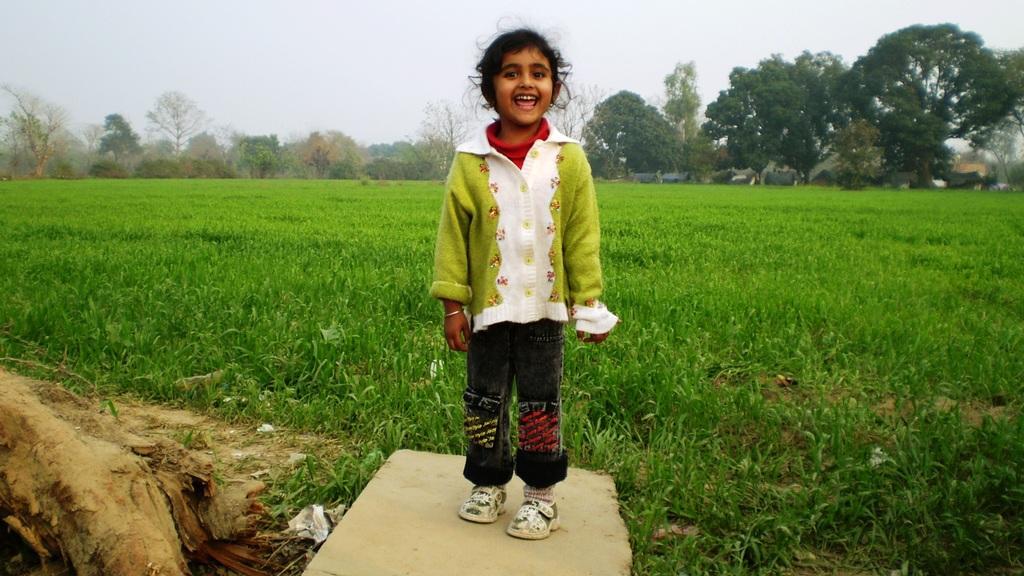Can you describe this image briefly? In this picture I can observe a girl standing on the cement block. The girl is smiling. Behind her there is some grass on the ground. In the background there are trees and a sky. 